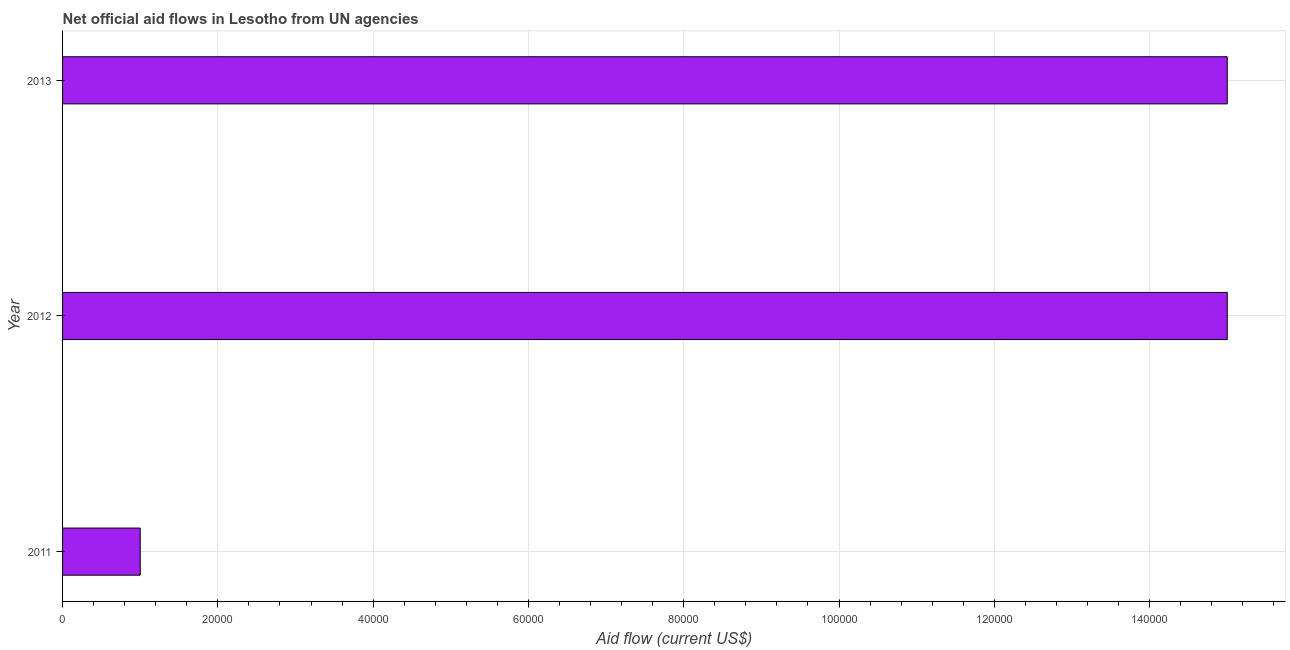Does the graph contain any zero values?
Your answer should be compact. No. What is the title of the graph?
Keep it short and to the point. Net official aid flows in Lesotho from UN agencies. What is the label or title of the X-axis?
Offer a very short reply. Aid flow (current US$). What is the label or title of the Y-axis?
Your response must be concise. Year. What is the sum of the net official flows from un agencies?
Provide a succinct answer. 3.10e+05. What is the average net official flows from un agencies per year?
Give a very brief answer. 1.03e+05. What is the median net official flows from un agencies?
Offer a very short reply. 1.50e+05. Do a majority of the years between 2011 and 2013 (inclusive) have net official flows from un agencies greater than 52000 US$?
Your answer should be very brief. Yes. What is the ratio of the net official flows from un agencies in 2011 to that in 2012?
Offer a very short reply. 0.07. Is the net official flows from un agencies in 2011 less than that in 2013?
Ensure brevity in your answer.  Yes. What is the difference between the highest and the second highest net official flows from un agencies?
Keep it short and to the point. 0. In how many years, is the net official flows from un agencies greater than the average net official flows from un agencies taken over all years?
Keep it short and to the point. 2. How many years are there in the graph?
Offer a terse response. 3. Are the values on the major ticks of X-axis written in scientific E-notation?
Offer a very short reply. No. What is the Aid flow (current US$) of 2011?
Offer a terse response. 10000. What is the Aid flow (current US$) of 2012?
Give a very brief answer. 1.50e+05. What is the Aid flow (current US$) of 2013?
Give a very brief answer. 1.50e+05. What is the difference between the Aid flow (current US$) in 2011 and 2013?
Keep it short and to the point. -1.40e+05. What is the difference between the Aid flow (current US$) in 2012 and 2013?
Give a very brief answer. 0. What is the ratio of the Aid flow (current US$) in 2011 to that in 2012?
Make the answer very short. 0.07. What is the ratio of the Aid flow (current US$) in 2011 to that in 2013?
Ensure brevity in your answer.  0.07. 